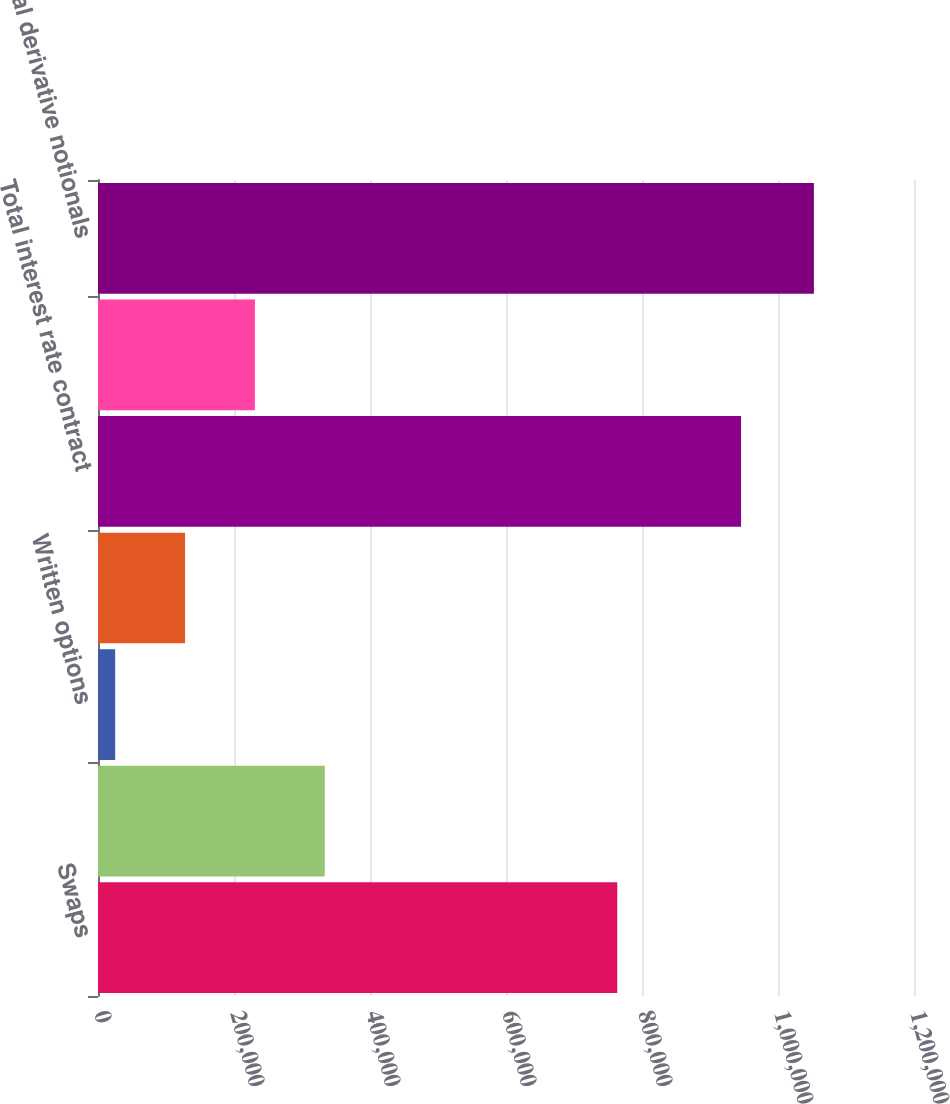Convert chart. <chart><loc_0><loc_0><loc_500><loc_500><bar_chart><fcel>Swaps<fcel>Futures and forwards<fcel>Written options<fcel>Purchased options<fcel>Total interest rate contract<fcel>Total foreign exchange<fcel>Total derivative notionals<nl><fcel>763630<fcel>333523<fcel>25255<fcel>128011<fcel>945669<fcel>230767<fcel>1.05282e+06<nl></chart> 